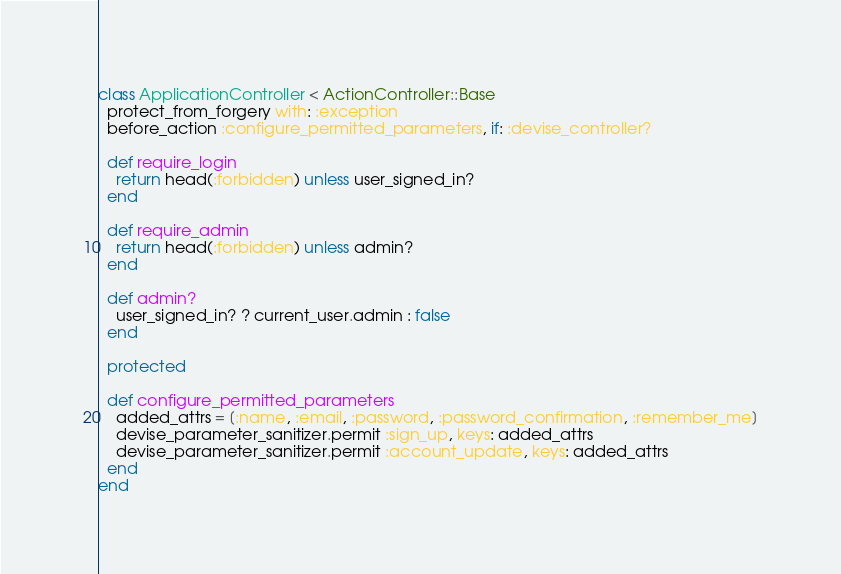Convert code to text. <code><loc_0><loc_0><loc_500><loc_500><_Ruby_>class ApplicationController < ActionController::Base
  protect_from_forgery with: :exception
  before_action :configure_permitted_parameters, if: :devise_controller?

  def require_login
    return head(:forbidden) unless user_signed_in?
  end

  def require_admin
    return head(:forbidden) unless admin?
  end

  def admin?
    user_signed_in? ? current_user.admin : false
  end

  protected

  def configure_permitted_parameters
    added_attrs = [:name, :email, :password, :password_confirmation, :remember_me]
    devise_parameter_sanitizer.permit :sign_up, keys: added_attrs
    devise_parameter_sanitizer.permit :account_update, keys: added_attrs
  end
end
</code> 